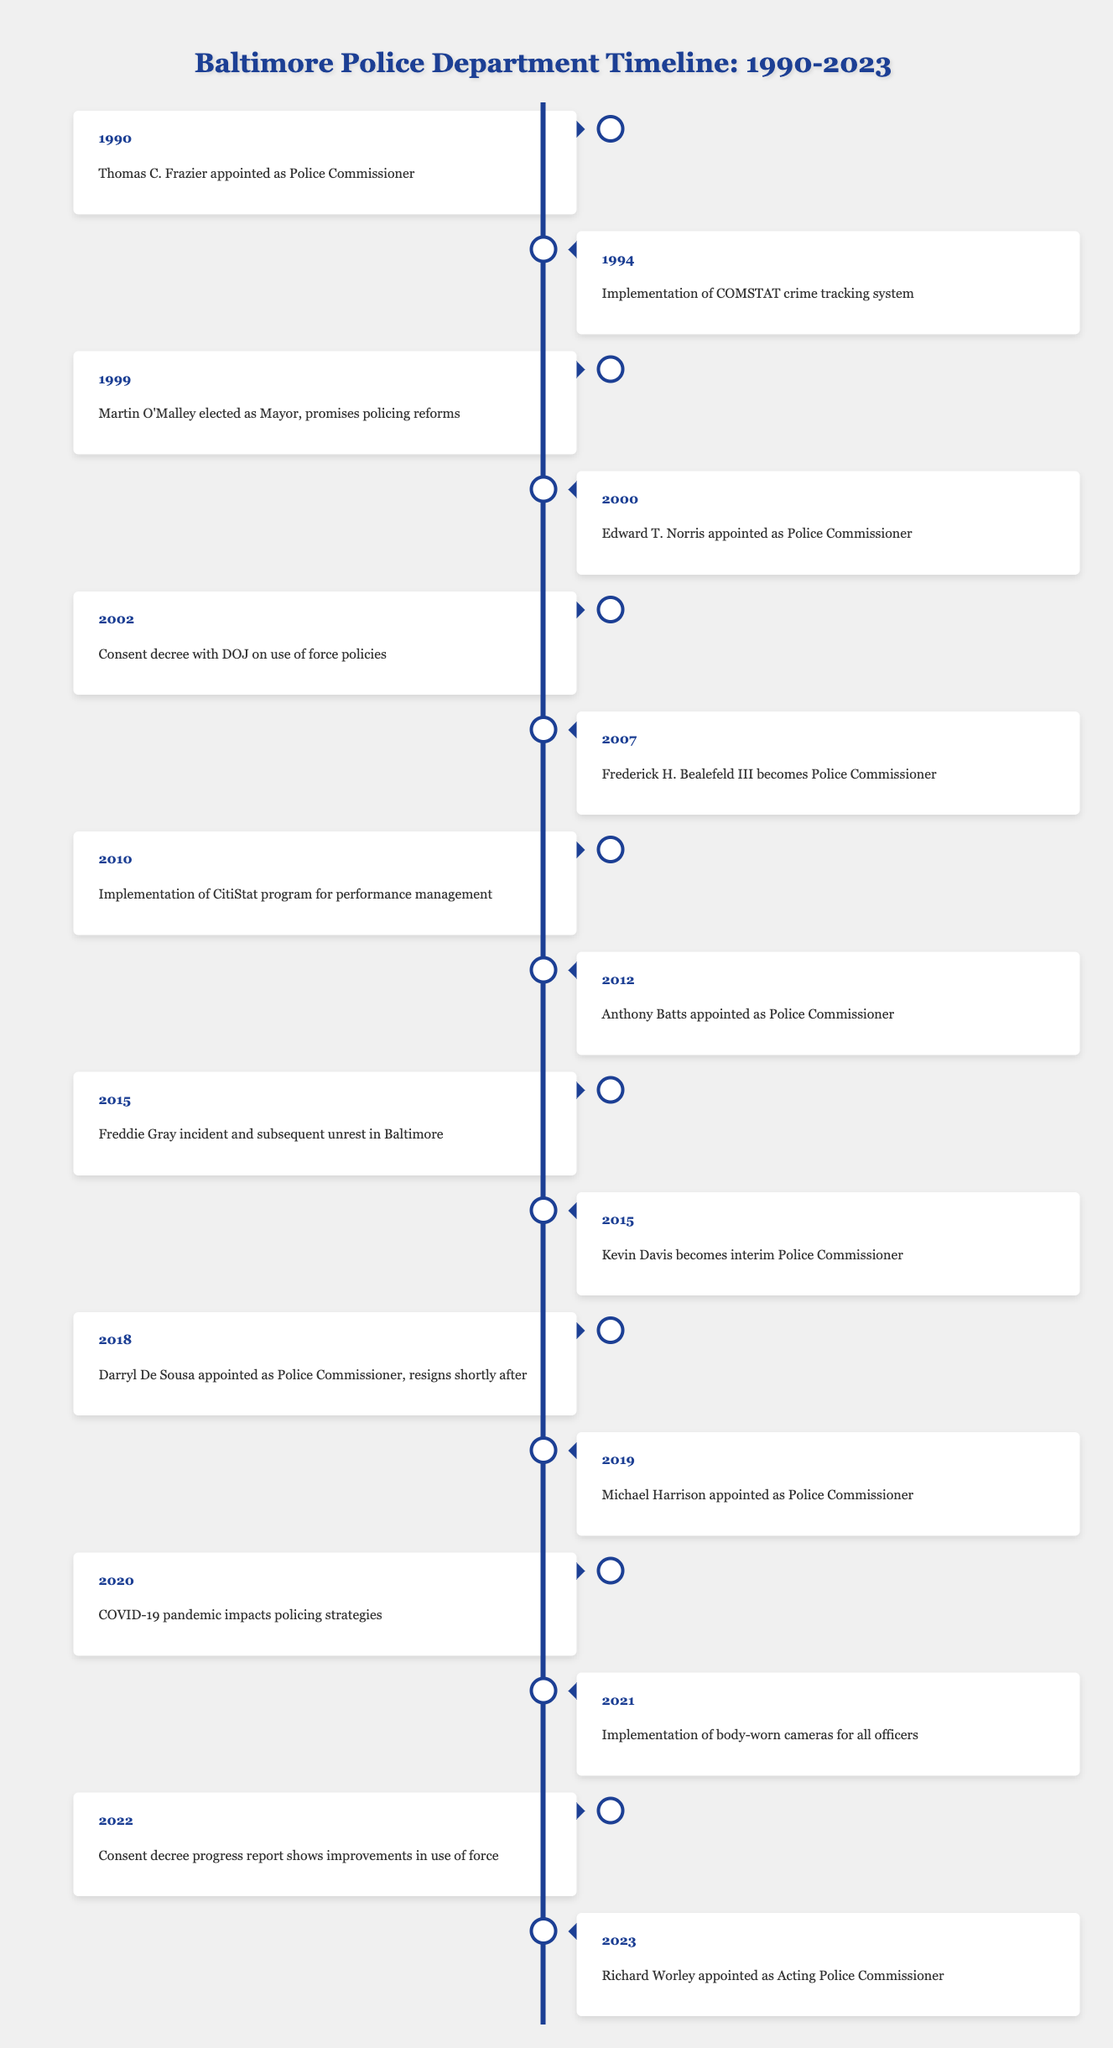What event took place in 2012? According to the timeline, in 2012, Anthony Batts was appointed as Police Commissioner.
Answer: Anthony Batts appointed as Police Commissioner How many Police Commissioners were appointed between 1990 and 2010? From 1990 to 2010, three individuals were appointed as Police Commissioner: Thomas C. Frazier in 1990, Edward T. Norris in 2000, and Frederick H. Bealefeld III in 2007.
Answer: Three Did the implementation of body-worn cameras happen before 2022? The timeline shows that the implementation of body-worn cameras for all officers occurred in 2021, which is before 2022.
Answer: Yes What is the difference between the years of the Freddie Gray incident and the consent decree with the DOJ? The Freddie Gray incident occurred in 2015, and the consent decree with the DOJ on use of force policies was established in 2002. The difference in years is 2015 - 2002 = 13 years.
Answer: 13 years In which years was there a change in Police Commissioner? The timeline indicates changes in Police Commissioner occurred in 1990 (Thomas C. Frazier), 2000 (Edward T. Norris), 2007 (Frederick H. Bealefeld III), 2012 (Anthony Batts), 2018 (Darryl De Sousa), 2019 (Michael Harrison), and 2023 (Richard Worley). Hence, the years are: 1990, 2000, 2007, 2012, 2018, 2019, 2023.
Answer: 1990, 2000, 2007, 2012, 2018, 2019, 2023 Which event was the latest before Richard Worley's appointment? The latest event before Richard Worley's appointment in 2023 was the consent decree progress report in 2022, which showed improvements in the use of force.
Answer: Consent decree progress report shows improvements in use of force 